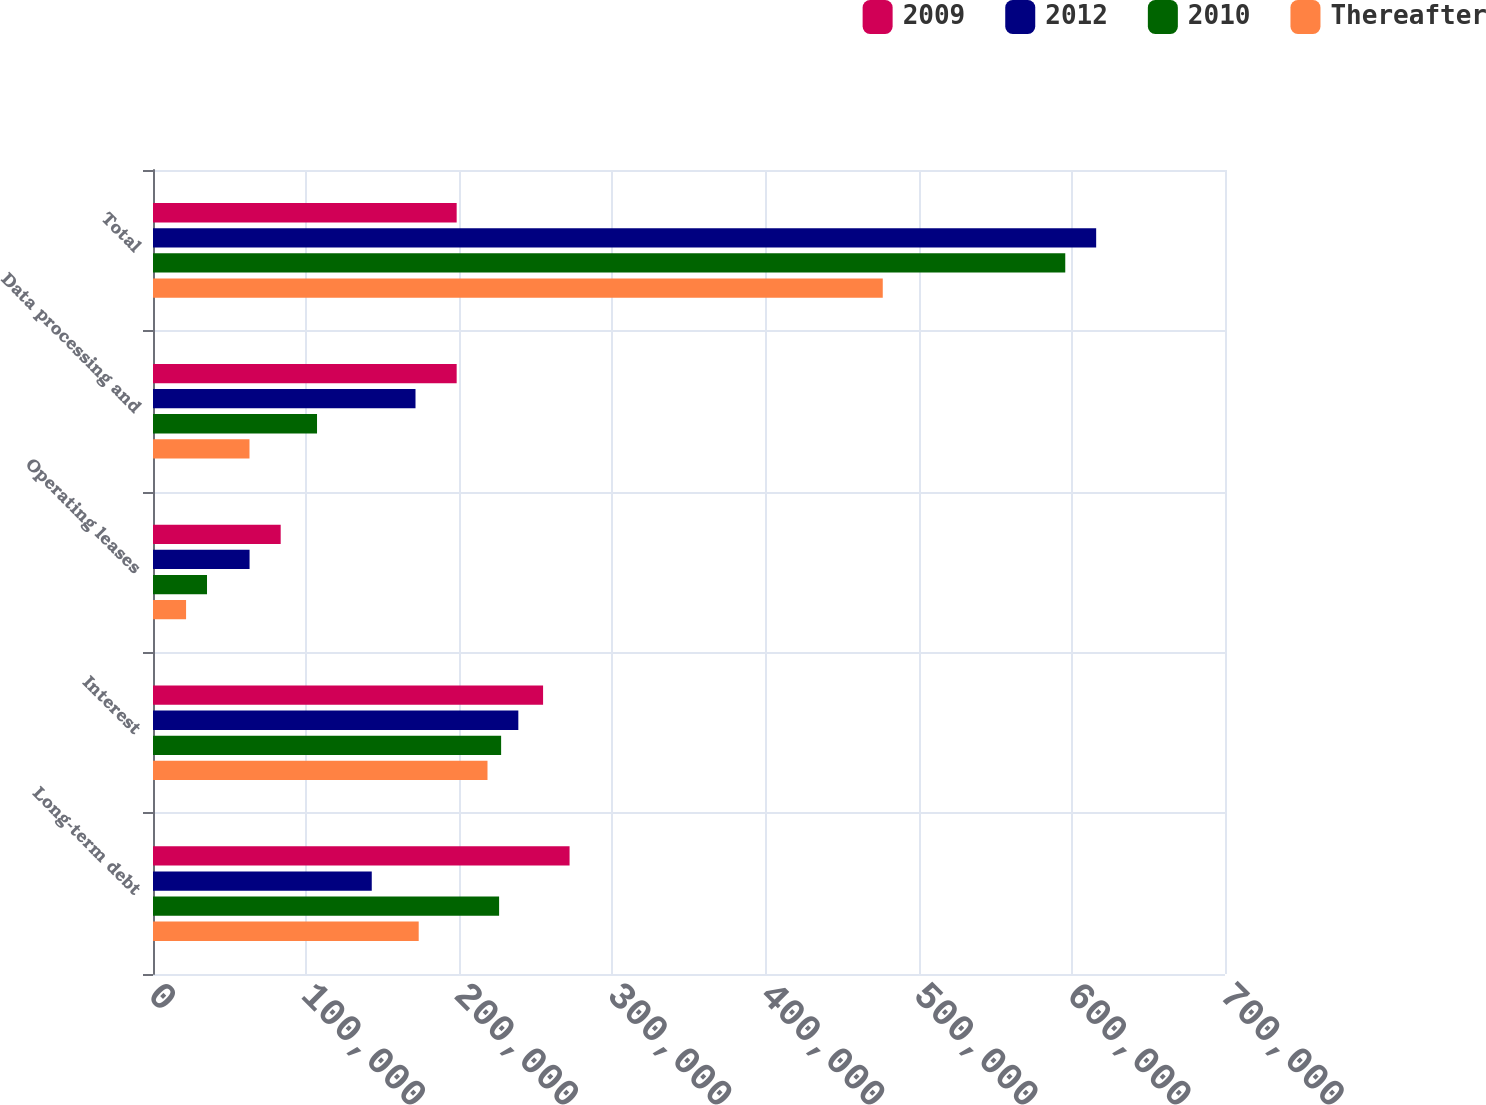<chart> <loc_0><loc_0><loc_500><loc_500><stacked_bar_chart><ecel><fcel>Long-term debt<fcel>Interest<fcel>Operating leases<fcel>Data processing and<fcel>Total<nl><fcel>2009<fcel>272014<fcel>254716<fcel>83382<fcel>198290<fcel>198290<nl><fcel>2012<fcel>142850<fcel>238554<fcel>63060<fcel>171411<fcel>615875<nl><fcel>2010<fcel>226000<fcel>227320<fcel>35269<fcel>107105<fcel>595694<nl><fcel>Thereafter<fcel>173500<fcel>218416<fcel>21598<fcel>63010<fcel>476524<nl></chart> 